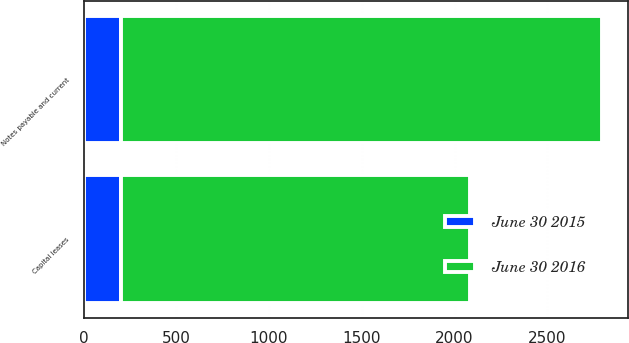<chart> <loc_0><loc_0><loc_500><loc_500><stacked_bar_chart><ecel><fcel>Capital leases<fcel>Notes payable and current<nl><fcel>June 30 2015<fcel>200<fcel>200<nl><fcel>June 30 2016<fcel>1881<fcel>2595<nl></chart> 